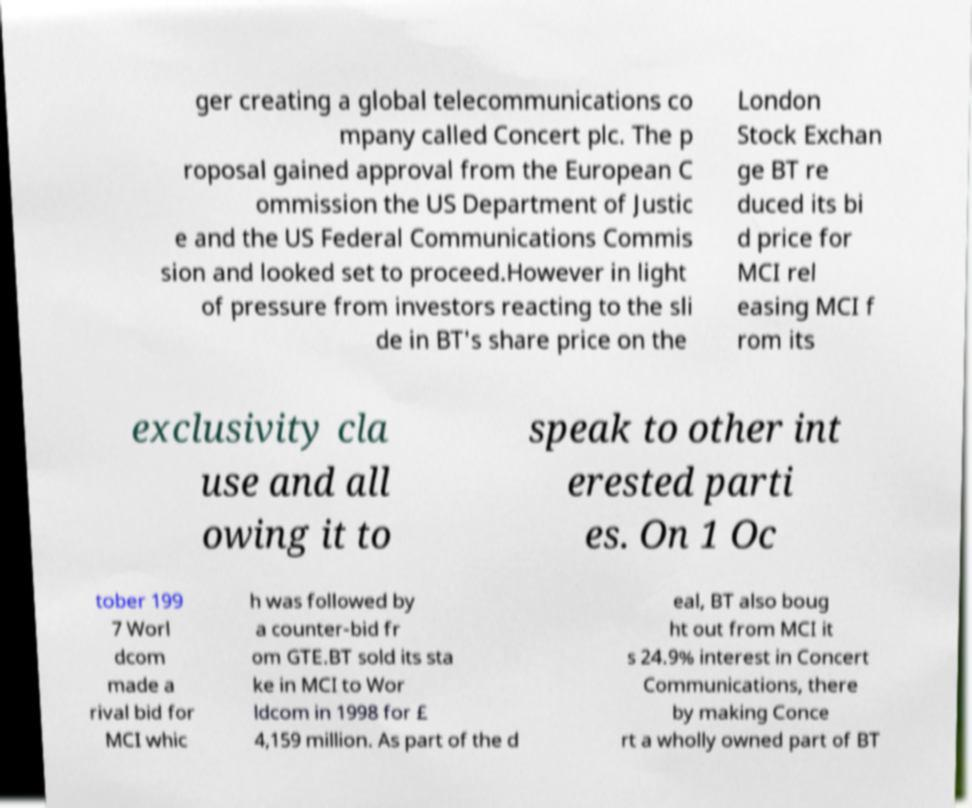There's text embedded in this image that I need extracted. Can you transcribe it verbatim? ger creating a global telecommunications co mpany called Concert plc. The p roposal gained approval from the European C ommission the US Department of Justic e and the US Federal Communications Commis sion and looked set to proceed.However in light of pressure from investors reacting to the sli de in BT's share price on the London Stock Exchan ge BT re duced its bi d price for MCI rel easing MCI f rom its exclusivity cla use and all owing it to speak to other int erested parti es. On 1 Oc tober 199 7 Worl dcom made a rival bid for MCI whic h was followed by a counter-bid fr om GTE.BT sold its sta ke in MCI to Wor ldcom in 1998 for £ 4,159 million. As part of the d eal, BT also boug ht out from MCI it s 24.9% interest in Concert Communications, there by making Conce rt a wholly owned part of BT 